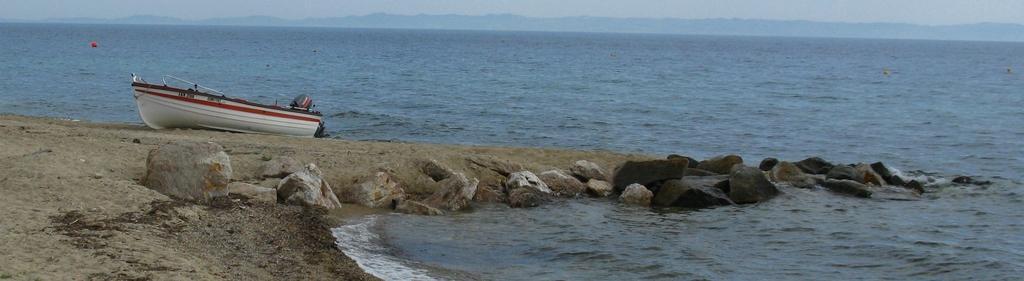In one or two sentences, can you explain what this image depicts? This picture is clicked outside. In the foreground we can see a water body and the rocks and we can see a white color boat. In the background we can see the sky and some other objects. 